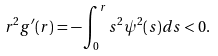<formula> <loc_0><loc_0><loc_500><loc_500>r ^ { 2 } g ^ { \prime } ( r ) = - \int _ { 0 } ^ { r } s ^ { 2 } \psi ^ { 2 } ( s ) d s < 0 .</formula> 